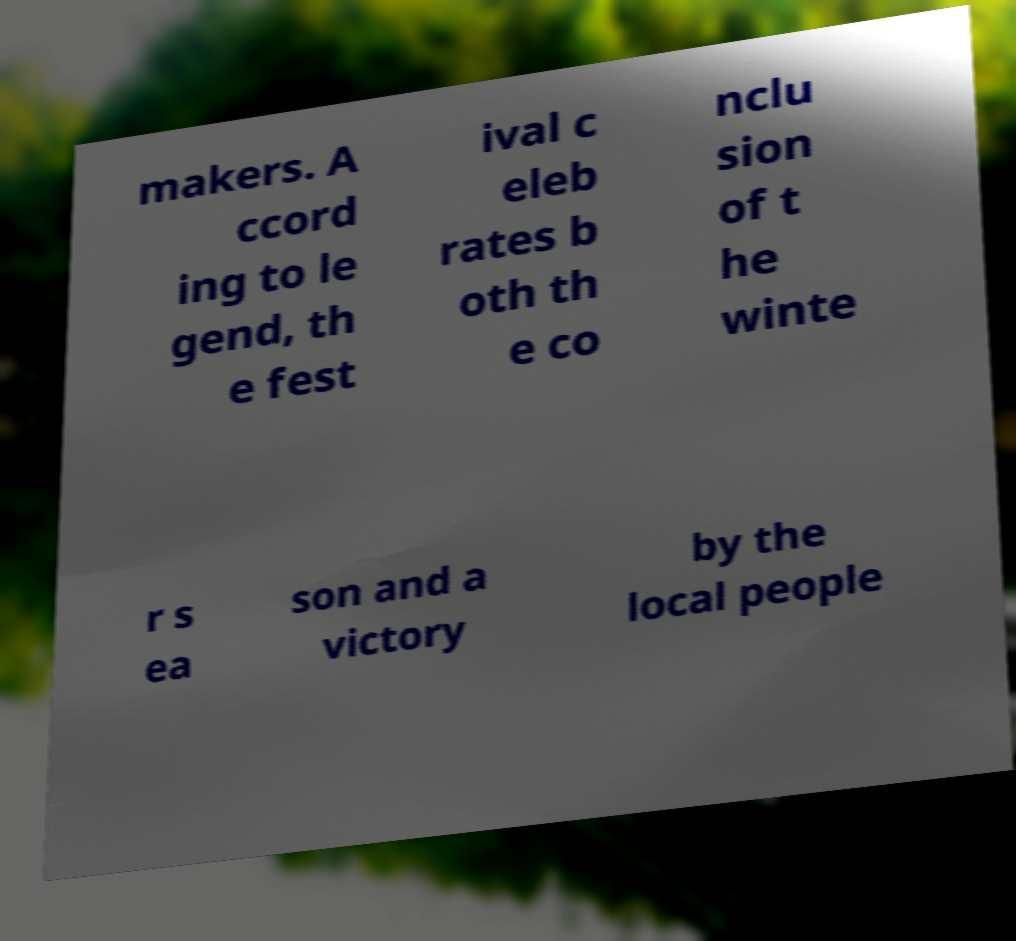Please identify and transcribe the text found in this image. makers. A ccord ing to le gend, th e fest ival c eleb rates b oth th e co nclu sion of t he winte r s ea son and a victory by the local people 